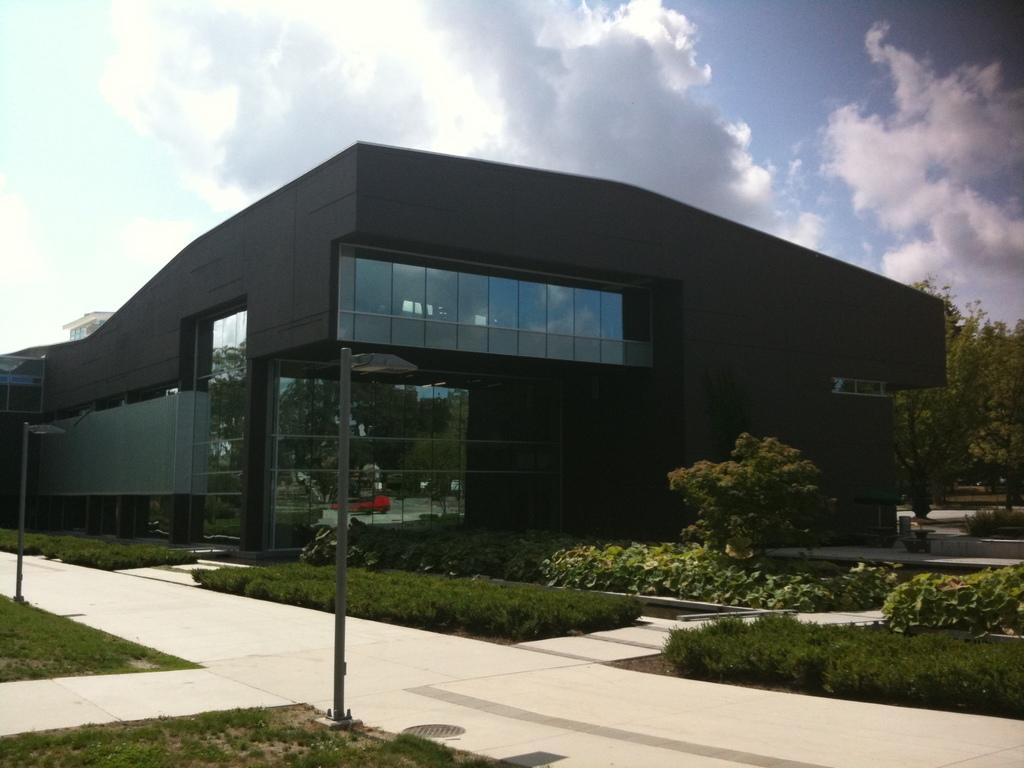What is the main subject of the image? There is a building at the center of the image. What is in front of the building? There is a path, grass, trees, and plants in front of the building. What can be seen in the background of the image? The sky is visible in the background of the image. How many babies are attempting to climb the mailbox in the image? There are no babies or mailbox present in the image. 